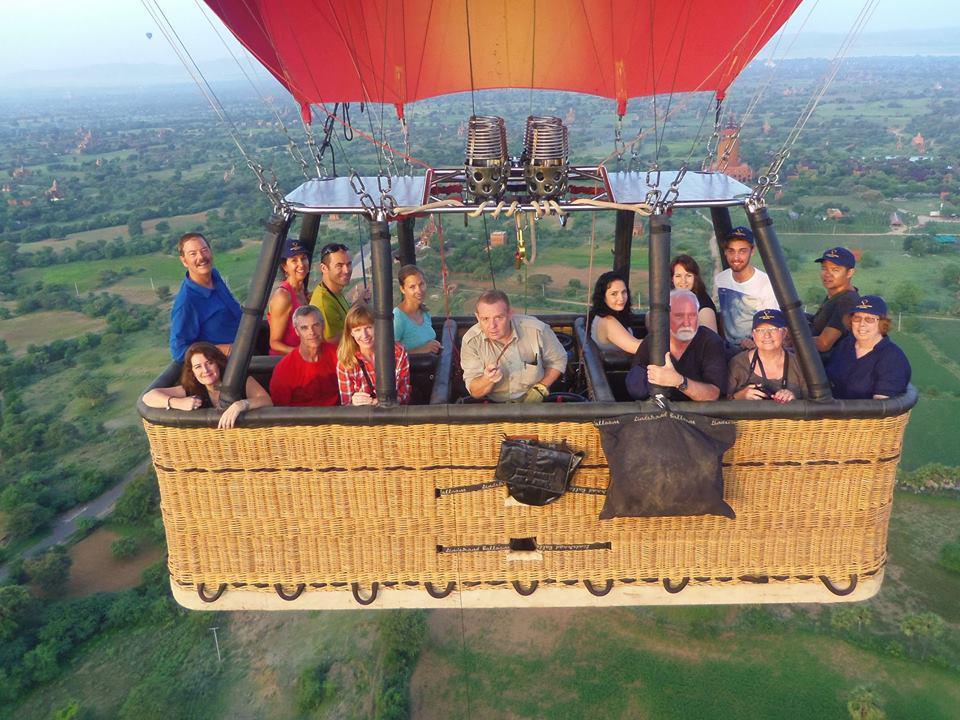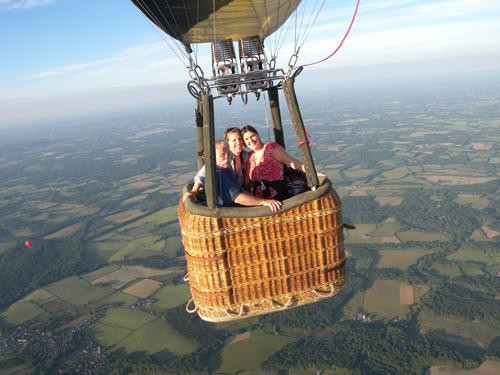The first image is the image on the left, the second image is the image on the right. Given the left and right images, does the statement "An image shows a person standing on the ground in a field with hot air balloon." hold true? Answer yes or no. No. The first image is the image on the left, the second image is the image on the right. Analyze the images presented: Is the assertion "Both images show people in hot air balloon baskets floating in midair." valid? Answer yes or no. Yes. 